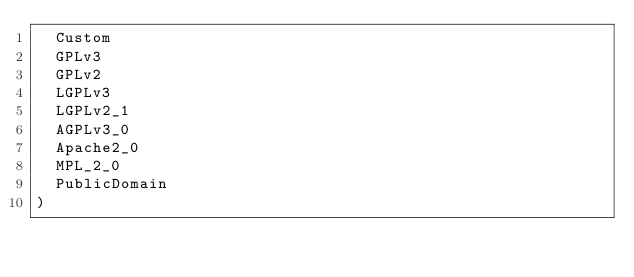Convert code to text. <code><loc_0><loc_0><loc_500><loc_500><_Go_>	Custom
	GPLv3
	GPLv2
	LGPLv3
	LGPLv2_1
	AGPLv3_0
	Apache2_0
	MPL_2_0
	PublicDomain
)
</code> 